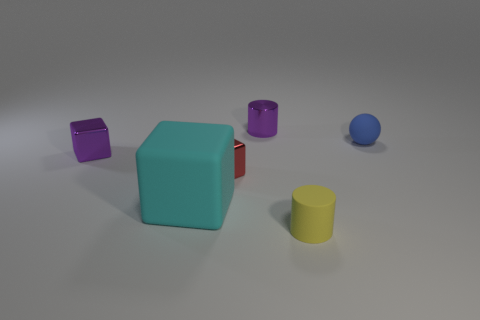Is there a yellow cylinder made of the same material as the red cube?
Give a very brief answer. No. Does the purple metallic object behind the blue sphere have the same size as the blue rubber thing?
Make the answer very short. Yes. What number of blue things are matte objects or large things?
Your answer should be compact. 1. There is a small cylinder that is behind the tiny blue object; what material is it?
Your answer should be compact. Metal. How many blue matte objects are to the left of the purple metallic thing in front of the small purple cylinder?
Offer a terse response. 0. What number of small red objects have the same shape as the big object?
Keep it short and to the point. 1. What number of small yellow cylinders are there?
Keep it short and to the point. 1. There is a tiny cube left of the big cyan rubber object; what color is it?
Offer a terse response. Purple. The shiny object that is behind the small purple shiny thing to the left of the metallic cylinder is what color?
Offer a terse response. Purple. There is a rubber ball that is the same size as the red metallic block; what color is it?
Make the answer very short. Blue. 